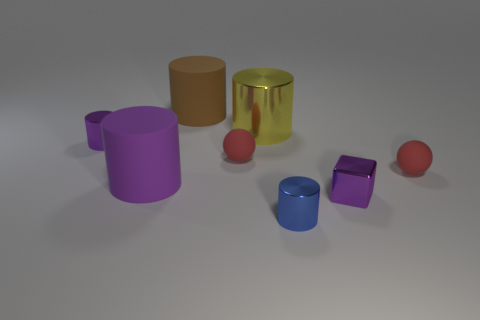What is the size of the shiny cylinder that is the same color as the block?
Ensure brevity in your answer.  Small. What is the material of the tiny cylinder that is the same color as the tiny block?
Your answer should be very brief. Metal. Are there any tiny metallic things that have the same shape as the large yellow thing?
Your answer should be compact. Yes. Does the block have the same size as the yellow object to the right of the big brown cylinder?
Your response must be concise. No. How many things are either small metal cylinders to the left of the tiny block or small purple objects to the left of the big brown rubber cylinder?
Provide a succinct answer. 2. Are there more small purple metallic objects on the left side of the purple rubber object than large brown blocks?
Offer a terse response. Yes. How many rubber balls have the same size as the purple cube?
Your answer should be very brief. 2. There is a matte ball that is on the right side of the small blue shiny cylinder; is its size the same as the rubber cylinder behind the large shiny thing?
Give a very brief answer. No. What is the size of the brown thing that is on the left side of the tiny purple block?
Offer a terse response. Large. There is a red rubber ball that is on the right side of the blue cylinder that is to the right of the purple matte thing; what is its size?
Ensure brevity in your answer.  Small. 